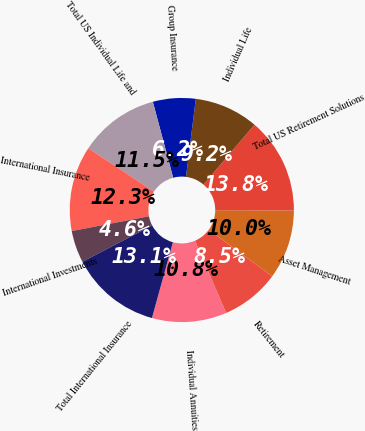<chart> <loc_0><loc_0><loc_500><loc_500><pie_chart><fcel>Individual Annuities<fcel>Retirement<fcel>Asset Management<fcel>Total US Retirement Solutions<fcel>Individual Life<fcel>Group Insurance<fcel>Total US Individual Life and<fcel>International Insurance<fcel>International Investments<fcel>Total International Insurance<nl><fcel>10.77%<fcel>8.46%<fcel>10.0%<fcel>13.84%<fcel>9.23%<fcel>6.16%<fcel>11.54%<fcel>12.3%<fcel>4.63%<fcel>13.07%<nl></chart> 